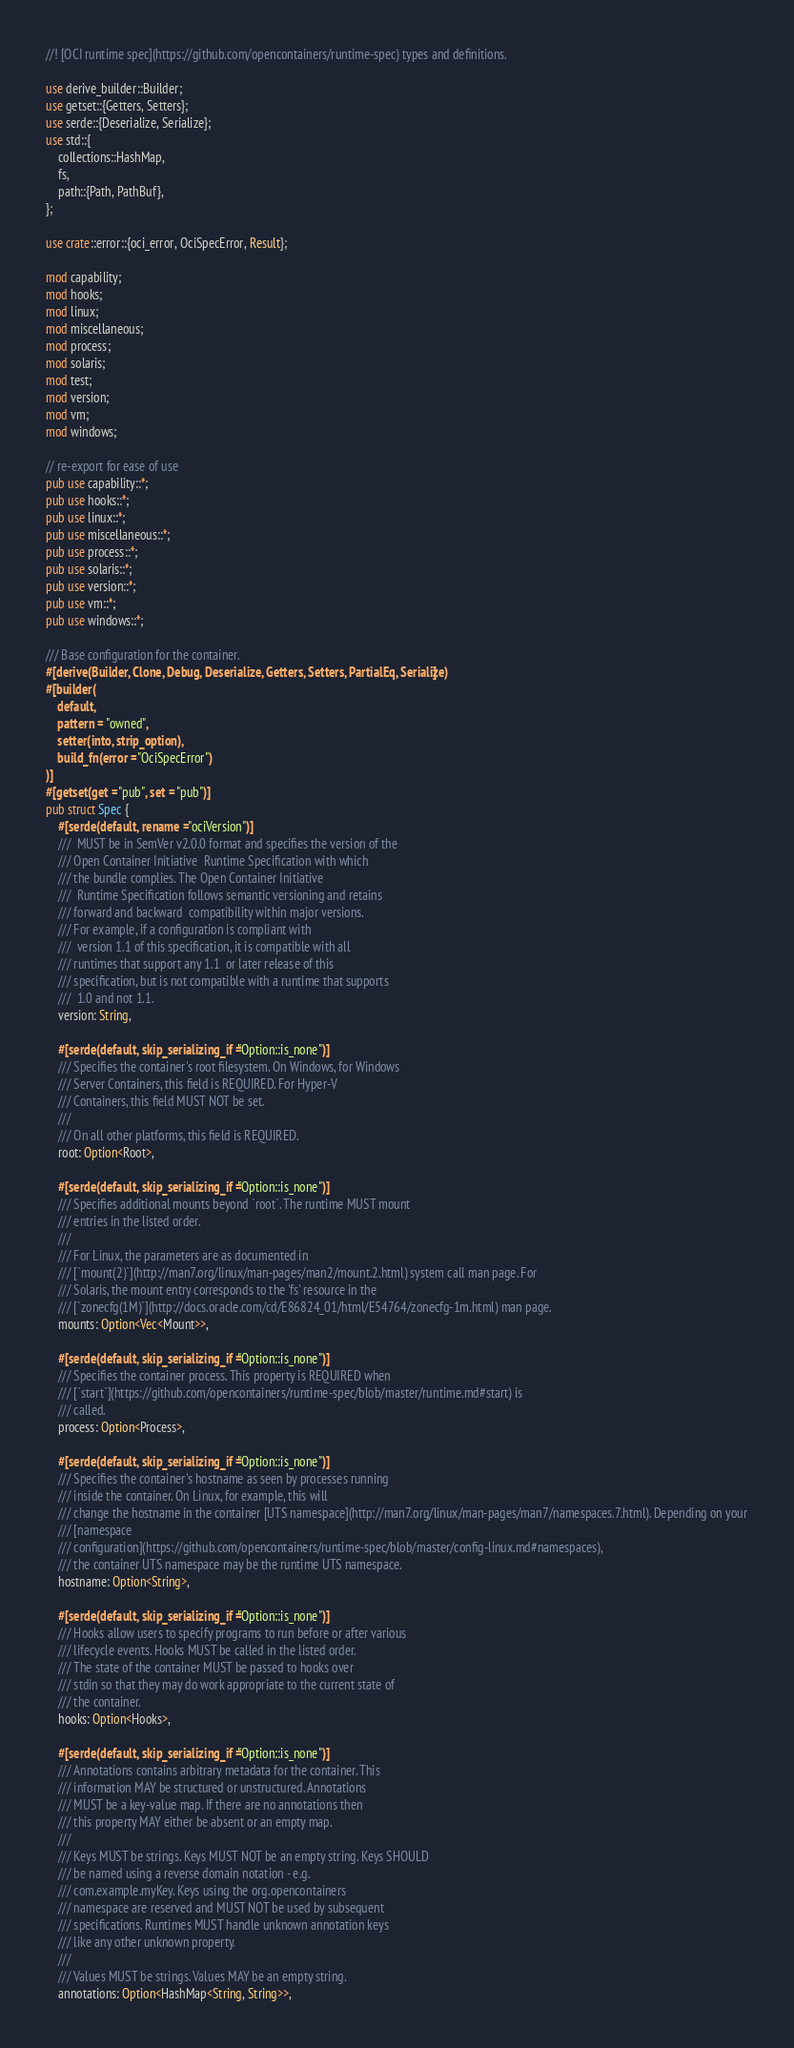Convert code to text. <code><loc_0><loc_0><loc_500><loc_500><_Rust_>//! [OCI runtime spec](https://github.com/opencontainers/runtime-spec) types and definitions.

use derive_builder::Builder;
use getset::{Getters, Setters};
use serde::{Deserialize, Serialize};
use std::{
    collections::HashMap,
    fs,
    path::{Path, PathBuf},
};

use crate::error::{oci_error, OciSpecError, Result};

mod capability;
mod hooks;
mod linux;
mod miscellaneous;
mod process;
mod solaris;
mod test;
mod version;
mod vm;
mod windows;

// re-export for ease of use
pub use capability::*;
pub use hooks::*;
pub use linux::*;
pub use miscellaneous::*;
pub use process::*;
pub use solaris::*;
pub use version::*;
pub use vm::*;
pub use windows::*;

/// Base configuration for the container.
#[derive(Builder, Clone, Debug, Deserialize, Getters, Setters, PartialEq, Serialize)]
#[builder(
    default,
    pattern = "owned",
    setter(into, strip_option),
    build_fn(error = "OciSpecError")
)]
#[getset(get = "pub", set = "pub")]
pub struct Spec {
    #[serde(default, rename = "ociVersion")]
    ///  MUST be in SemVer v2.0.0 format and specifies the version of the
    /// Open Container Initiative  Runtime Specification with which
    /// the bundle complies. The Open Container Initiative
    ///  Runtime Specification follows semantic versioning and retains
    /// forward and backward  compatibility within major versions.
    /// For example, if a configuration is compliant with
    ///  version 1.1 of this specification, it is compatible with all
    /// runtimes that support any 1.1  or later release of this
    /// specification, but is not compatible with a runtime that supports
    ///  1.0 and not 1.1.
    version: String,

    #[serde(default, skip_serializing_if = "Option::is_none")]
    /// Specifies the container's root filesystem. On Windows, for Windows
    /// Server Containers, this field is REQUIRED. For Hyper-V
    /// Containers, this field MUST NOT be set.
    ///
    /// On all other platforms, this field is REQUIRED.
    root: Option<Root>,

    #[serde(default, skip_serializing_if = "Option::is_none")]
    /// Specifies additional mounts beyond `root`. The runtime MUST mount
    /// entries in the listed order.
    ///
    /// For Linux, the parameters are as documented in
    /// [`mount(2)`](http://man7.org/linux/man-pages/man2/mount.2.html) system call man page. For
    /// Solaris, the mount entry corresponds to the 'fs' resource in the
    /// [`zonecfg(1M)`](http://docs.oracle.com/cd/E86824_01/html/E54764/zonecfg-1m.html) man page.
    mounts: Option<Vec<Mount>>,

    #[serde(default, skip_serializing_if = "Option::is_none")]
    /// Specifies the container process. This property is REQUIRED when
    /// [`start`](https://github.com/opencontainers/runtime-spec/blob/master/runtime.md#start) is
    /// called.
    process: Option<Process>,

    #[serde(default, skip_serializing_if = "Option::is_none")]
    /// Specifies the container's hostname as seen by processes running
    /// inside the container. On Linux, for example, this will
    /// change the hostname in the container [UTS namespace](http://man7.org/linux/man-pages/man7/namespaces.7.html). Depending on your
    /// [namespace
    /// configuration](https://github.com/opencontainers/runtime-spec/blob/master/config-linux.md#namespaces),
    /// the container UTS namespace may be the runtime UTS namespace.
    hostname: Option<String>,

    #[serde(default, skip_serializing_if = "Option::is_none")]
    /// Hooks allow users to specify programs to run before or after various
    /// lifecycle events. Hooks MUST be called in the listed order.
    /// The state of the container MUST be passed to hooks over
    /// stdin so that they may do work appropriate to the current state of
    /// the container.
    hooks: Option<Hooks>,

    #[serde(default, skip_serializing_if = "Option::is_none")]
    /// Annotations contains arbitrary metadata for the container. This
    /// information MAY be structured or unstructured. Annotations
    /// MUST be a key-value map. If there are no annotations then
    /// this property MAY either be absent or an empty map.
    ///
    /// Keys MUST be strings. Keys MUST NOT be an empty string. Keys SHOULD
    /// be named using a reverse domain notation - e.g.
    /// com.example.myKey. Keys using the org.opencontainers
    /// namespace are reserved and MUST NOT be used by subsequent
    /// specifications. Runtimes MUST handle unknown annotation keys
    /// like any other unknown property.
    ///
    /// Values MUST be strings. Values MAY be an empty string.
    annotations: Option<HashMap<String, String>>,
</code> 